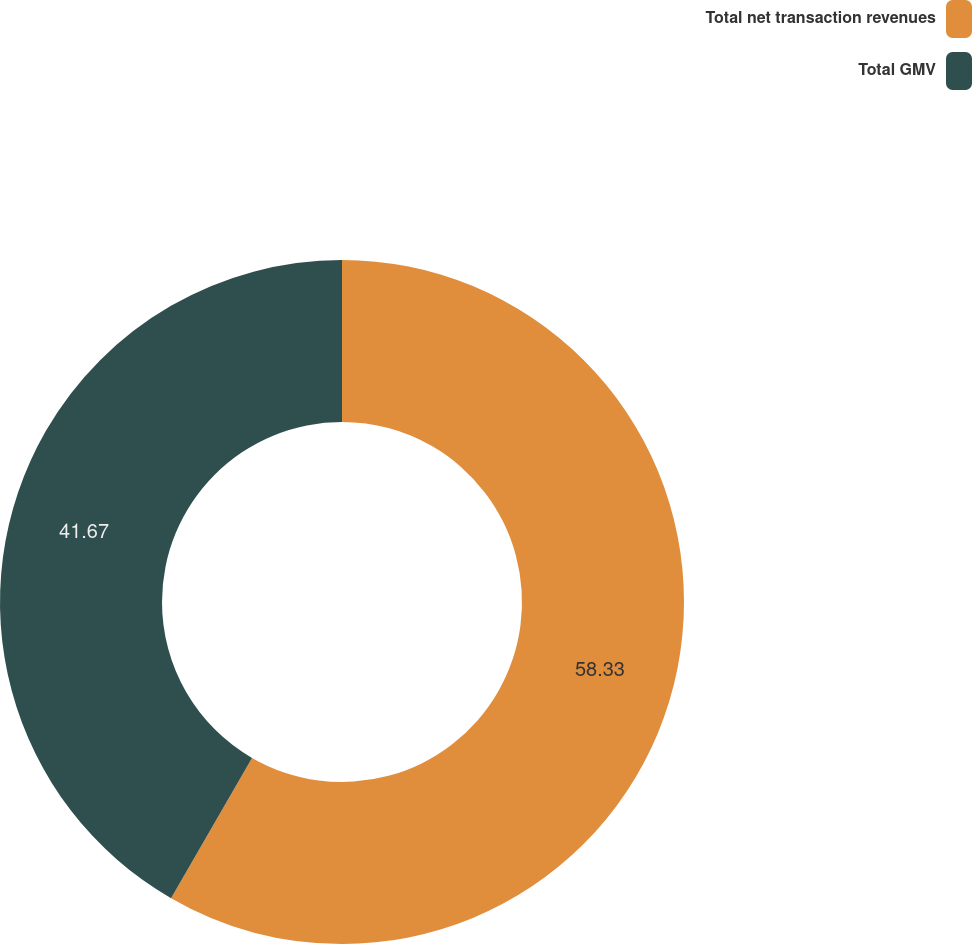<chart> <loc_0><loc_0><loc_500><loc_500><pie_chart><fcel>Total net transaction revenues<fcel>Total GMV<nl><fcel>58.33%<fcel>41.67%<nl></chart> 